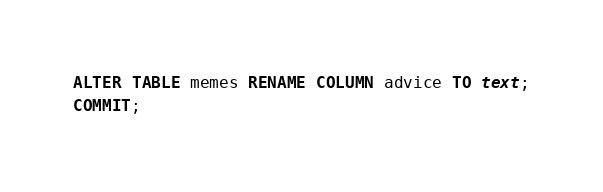<code> <loc_0><loc_0><loc_500><loc_500><_SQL_>ALTER TABLE memes RENAME COLUMN advice TO text;
COMMIT;</code> 